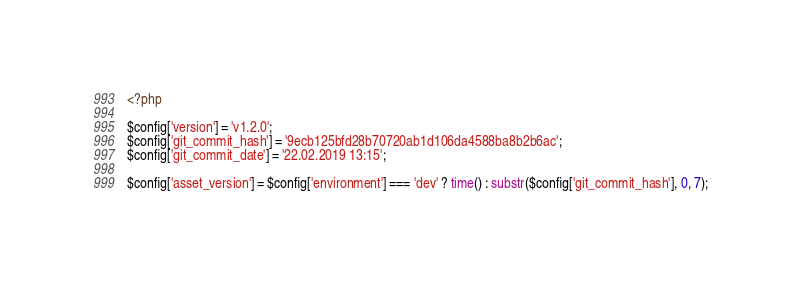<code> <loc_0><loc_0><loc_500><loc_500><_PHP_><?php

$config['version'] = 'v1.2.0';
$config['git_commit_hash'] = '9ecb125bfd28b70720ab1d106da4588ba8b2b6ac';
$config['git_commit_date'] = '22.02.2019 13:15';

$config['asset_version'] = $config['environment'] === 'dev' ? time() : substr($config['git_commit_hash'], 0, 7);
</code> 